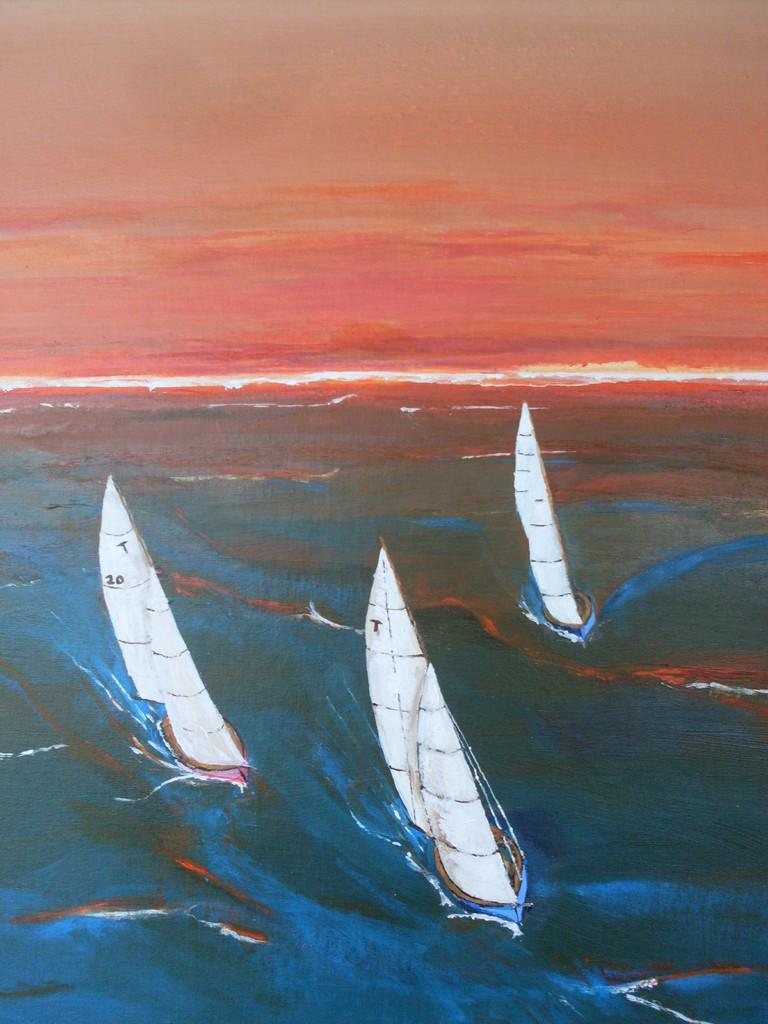What type of image is depicted in the picture? The image contains a portrait. What is the subject matter of the portrait? The portrait consists of ships. Where are the ships located in the portrait? The ships are on the water. What type of lead can be seen in the portrait? There is no lead present in the portrait; it features ships on the water. What religious symbolism is depicted in the portrait? There is no religious symbolism present in the portrait; it consists solely of ships on the water. 